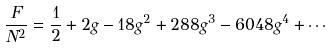Convert formula to latex. <formula><loc_0><loc_0><loc_500><loc_500>\frac { F } { N ^ { 2 } } = \frac { 1 } { 2 } + 2 g - 1 8 g ^ { 2 } + 2 8 8 g ^ { 3 } - 6 0 4 8 g ^ { 4 } + \cdots</formula> 